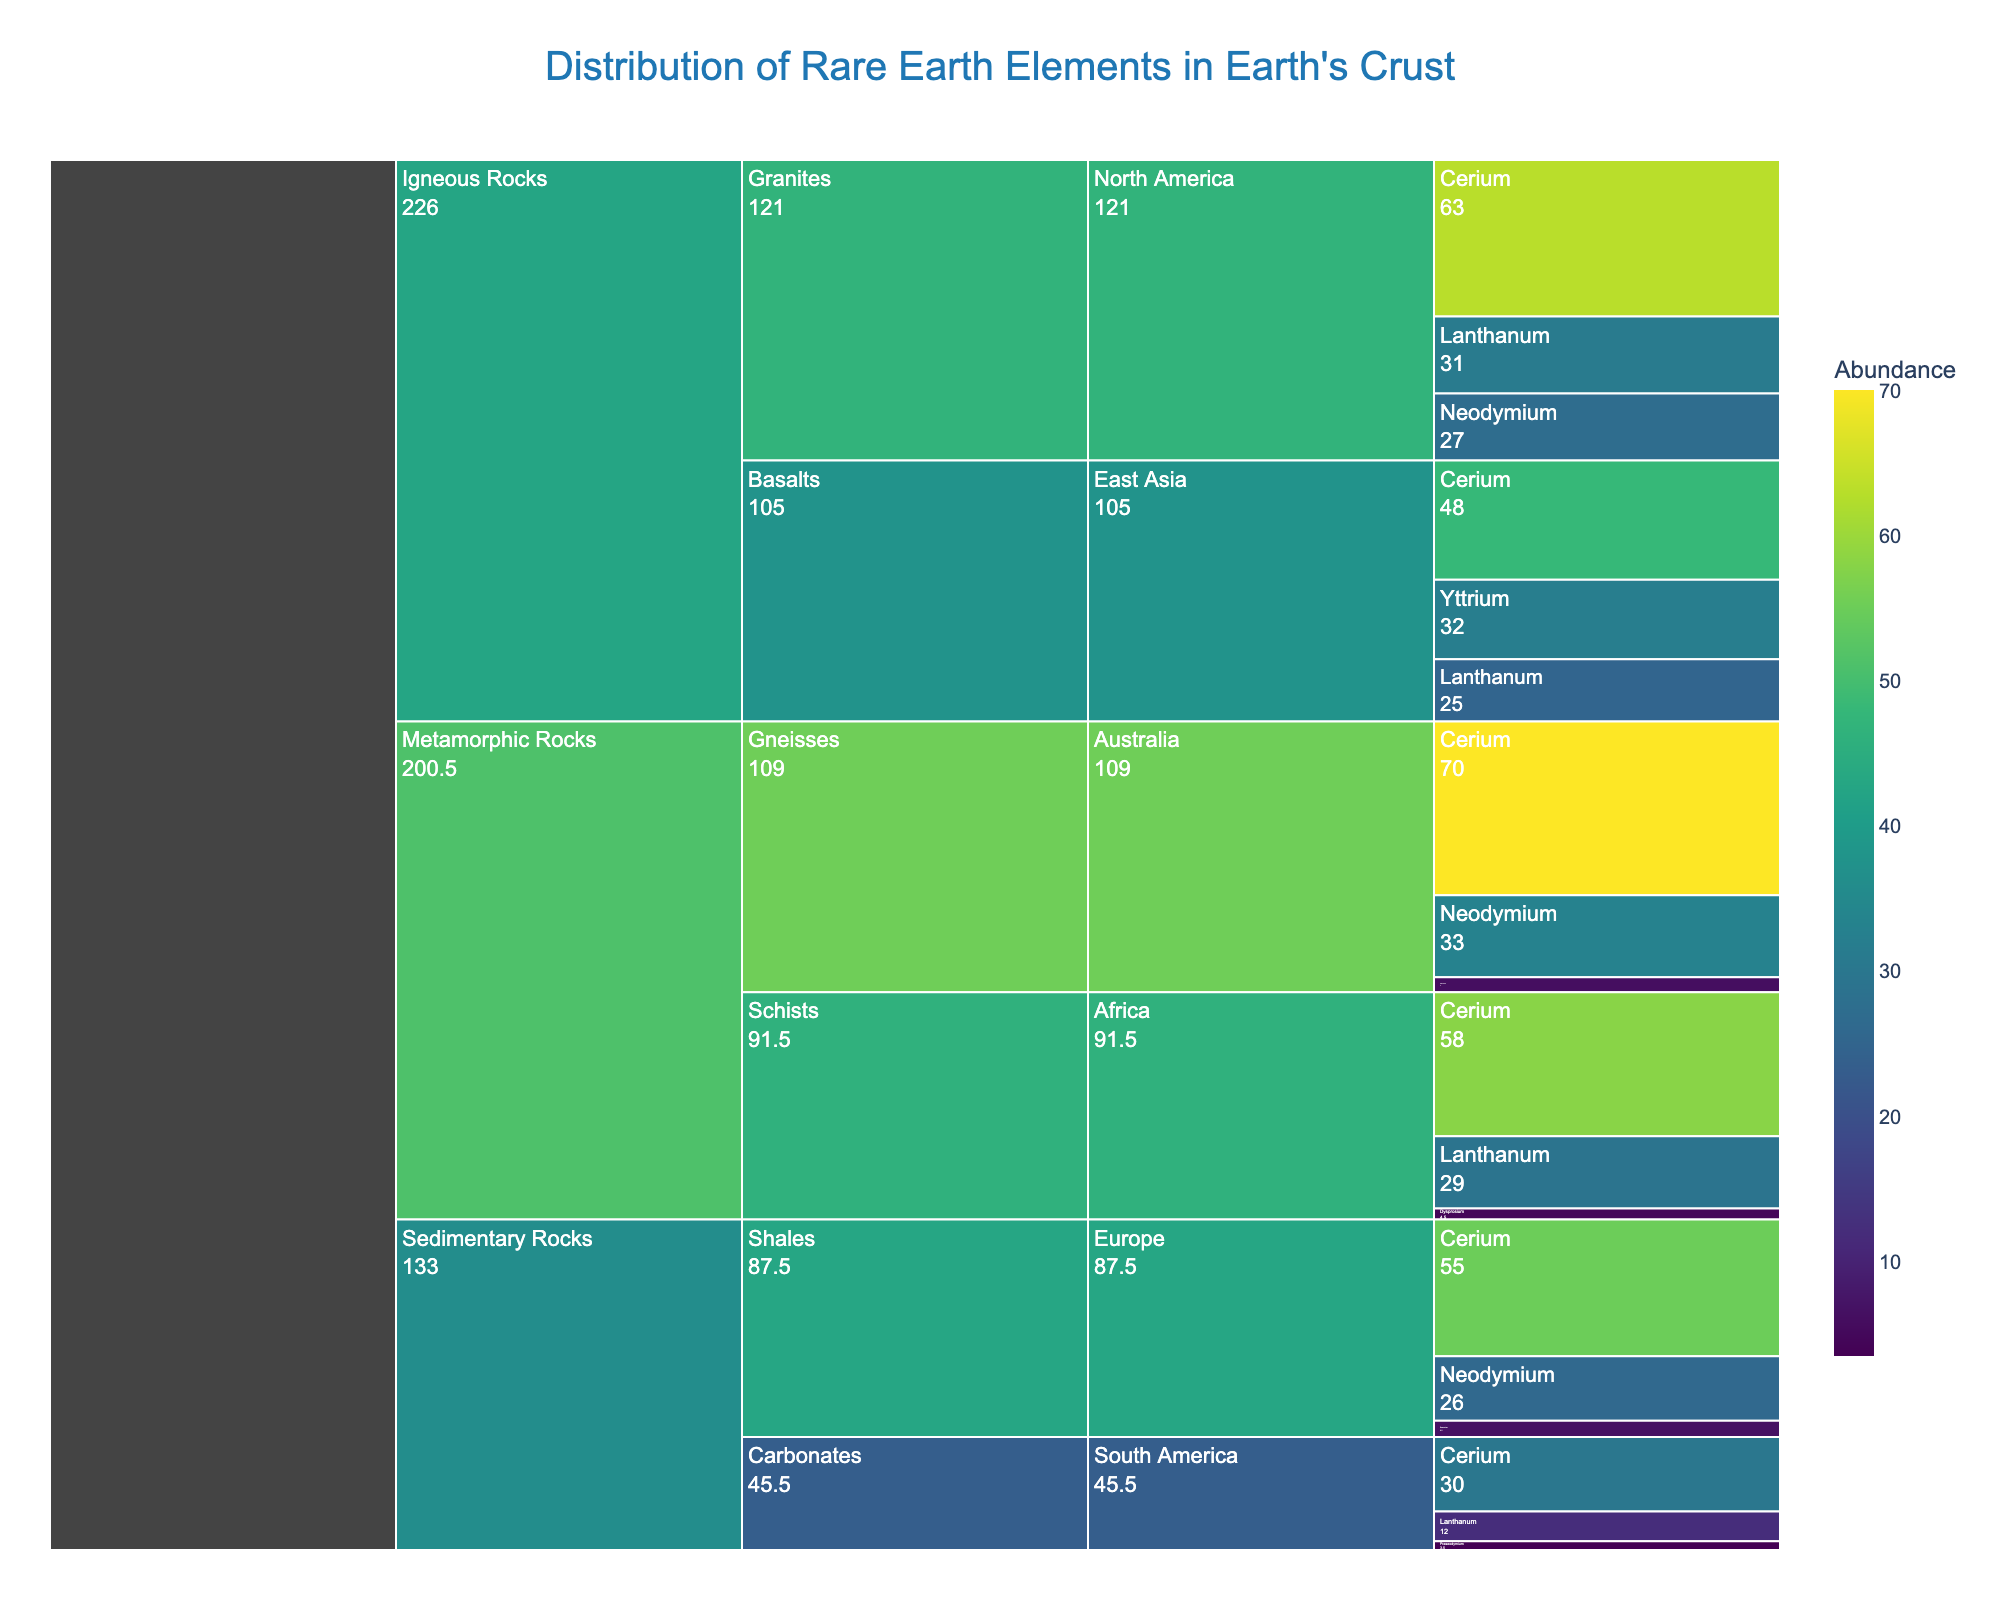What is the title of the chart? The title of the chart is prominently displayed at the top and indicates the subject of the visualization. It reads "Distribution of Rare Earth Elements in Earth's Crust".
Answer: Distribution of Rare Earth Elements in Earth's Crust Which geological formation in North America has the highest abundance of Cerium? Look for North America under each formation and locate Cerium. Compare the abundance values of Cerium across those formations. For North America, under Granites, Cerium has an abundance of 63, which is the highest in that region.
Answer: Granites How many elements are listed under Igneous Rocks? Look under the category "Igneous Rocks" and count the total unique elements listed in both Granites and Basalts formations. Elements under Igneous Rocks are Cerium, Lanthanum, Neodymium (Granites) and Cerium, Yttrium, Lanthanum (Basalts), summing up to 5 unique elements (Cerium is counted once).
Answer: 5 Which element has the highest abundance across all geological formations? Compare the abundance values of all elements listed across the different formations. Cerium in Gneisses (Metamorphic Rocks) has an abundance of 70, which is the highest value.
Answer: Cerium What is the total abundance of rare earth elements in the Gneisses formation in Australia? Sum the abundance values of all elements listed under Gneisses in Australia. These are Cerium (70), Neodymium (33), and Gadolinium (6). 70 + 33 + 6 equals 109.
Answer: 109 What is the difference in abundance of Cerium between Granites in North America and Basalts in East Asia? Subtract the abundance of Cerium in Basalts (East Asia) from that in Granites (North America). That is, 63 - 48 equals 15.
Answer: 15 Which region has the least abundance of Lanthanum in any formation? Compare the abundance values of Lanthanum across all regions and look for the smallest value. South America has a Lanthanum abundance of 12 in Carbonates, which is the smallest.
Answer: South America What is the total abundance of rare earth elements in Sedimentary Rocks across all regions? Sum the abundance values of elements listed under Sedimentary Rocks across all regions: Cerium (55) + Neodymium (26) + Samarium (6.5) + Lanthanum (12) + Cerium (30) + Praseodymium (3.5). 55 + 26 + 6.5 + 12 + 30 + 3.5 equals 133.
Answer: 133 Which category has the highest cumulative abundance of rare earth elements? Sum the abundance values of all elements listed under each category. Categories are: Igneous Rocks (Cerium 63 + Lanthanum 31 + Neodymium 27 + Cerium 48 + Yttrium 32 + Lanthanum 25 = 226), Sedimentary Rocks (already found 133), Metamorphic Rocks (Cerium 70 + Neodymium 33 + Gadolinium 6 + Lanthanum 29 + Cerium 58 + Dysprosium 4.5 = 200.5). Igneous Rocks has the highest cumulative abundance.
Answer: Igneous Rocks 